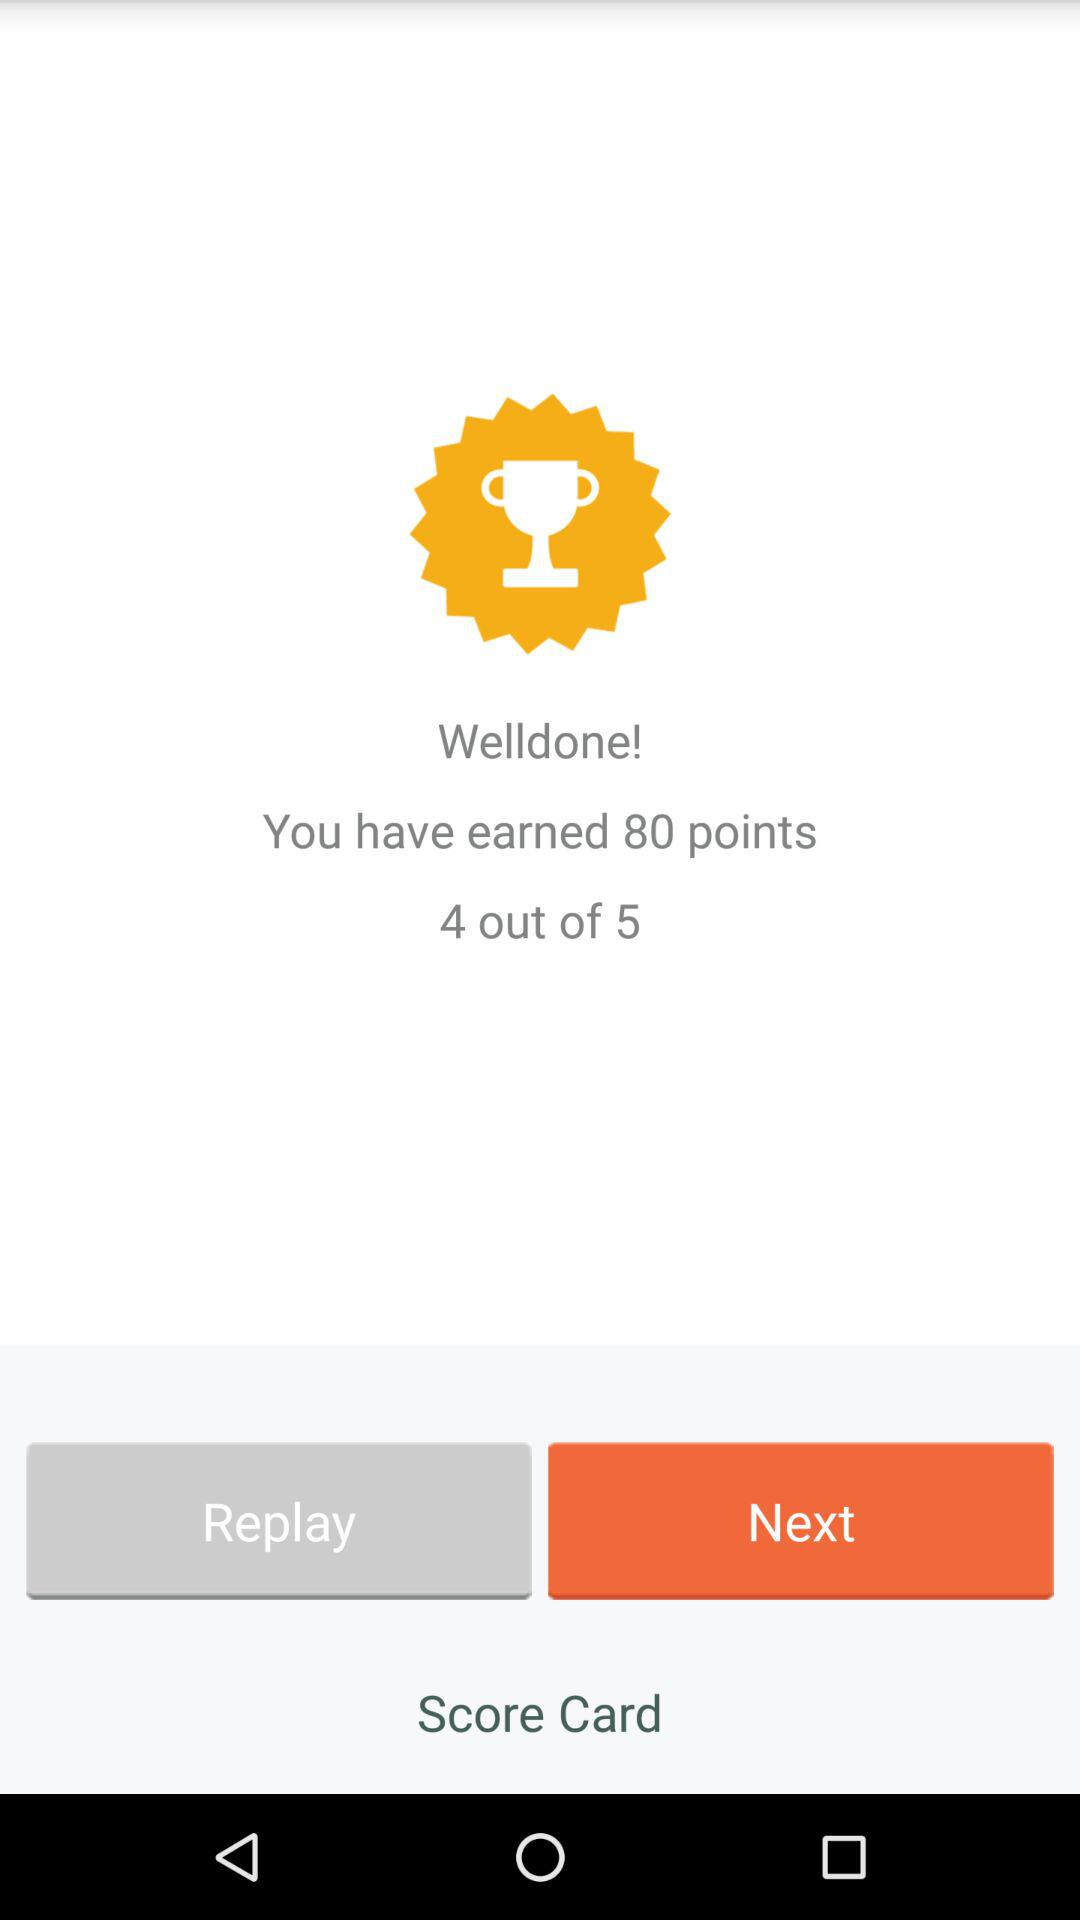What is the score given on the screen? The score given on the screen is 4 out of 5. 